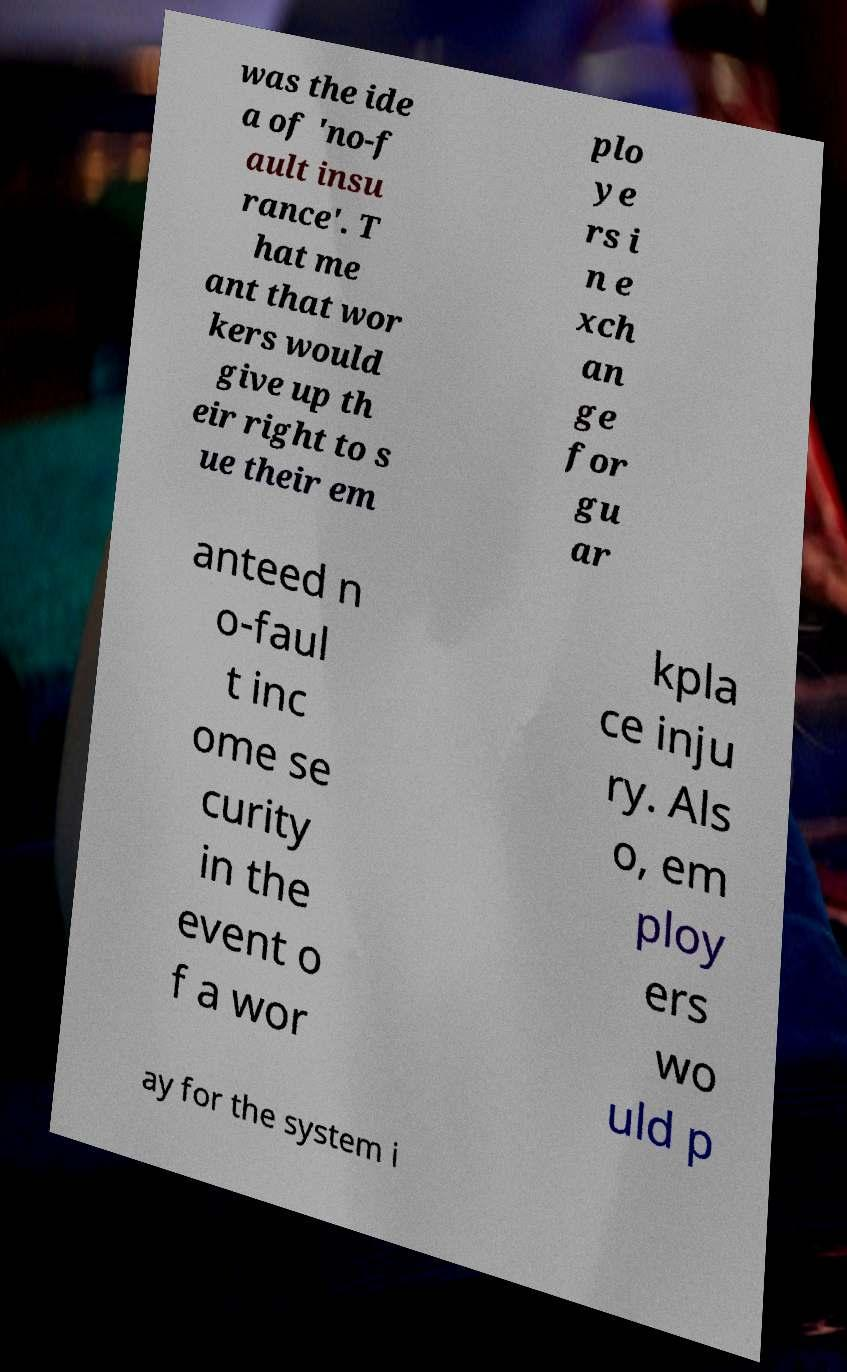Please identify and transcribe the text found in this image. was the ide a of 'no-f ault insu rance'. T hat me ant that wor kers would give up th eir right to s ue their em plo ye rs i n e xch an ge for gu ar anteed n o-faul t inc ome se curity in the event o f a wor kpla ce inju ry. Als o, em ploy ers wo uld p ay for the system i 